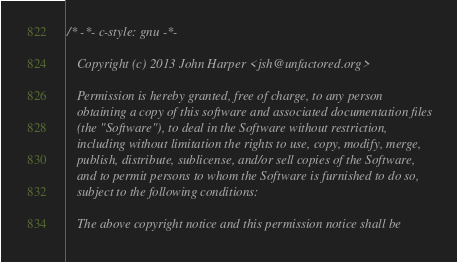Convert code to text. <code><loc_0><loc_0><loc_500><loc_500><_ObjectiveC_>/* -*- c-style: gnu -*-

   Copyright (c) 2013 John Harper <jsh@unfactored.org>

   Permission is hereby granted, free of charge, to any person
   obtaining a copy of this software and associated documentation files
   (the "Software"), to deal in the Software without restriction,
   including without limitation the rights to use, copy, modify, merge,
   publish, distribute, sublicense, and/or sell copies of the Software,
   and to permit persons to whom the Software is furnished to do so,
   subject to the following conditions:

   The above copyright notice and this permission notice shall be</code> 